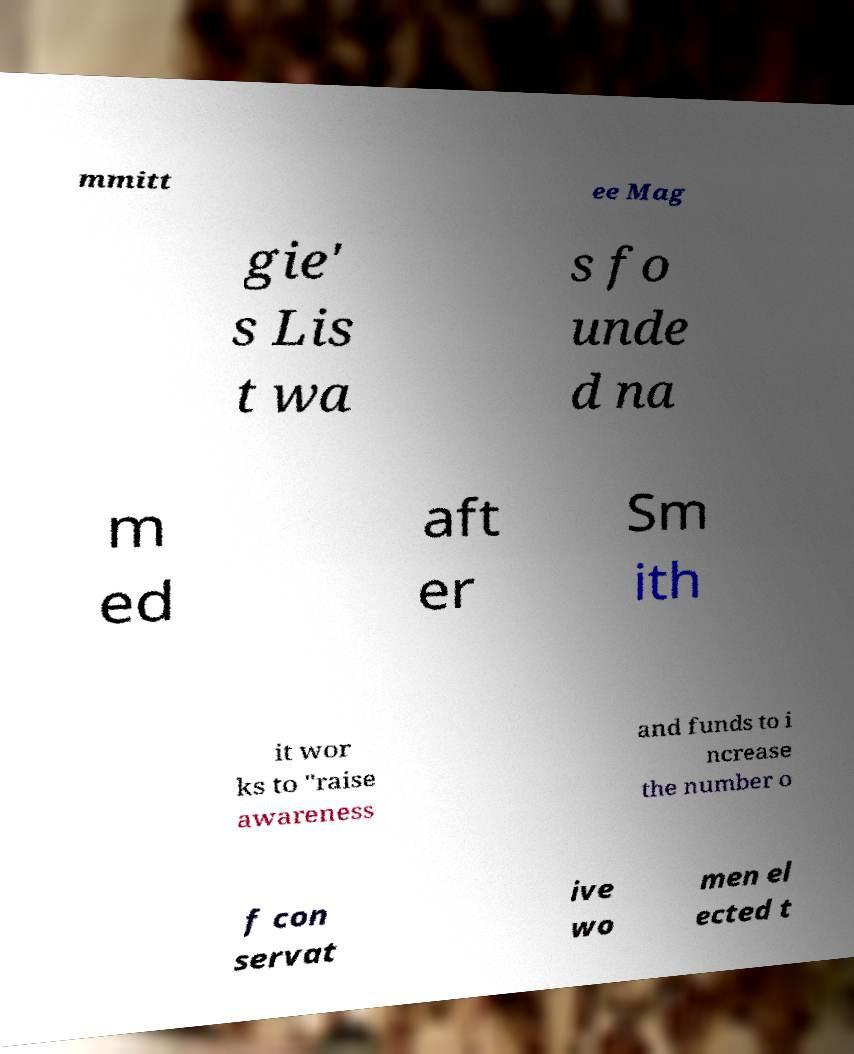Could you extract and type out the text from this image? mmitt ee Mag gie' s Lis t wa s fo unde d na m ed aft er Sm ith it wor ks to "raise awareness and funds to i ncrease the number o f con servat ive wo men el ected t 